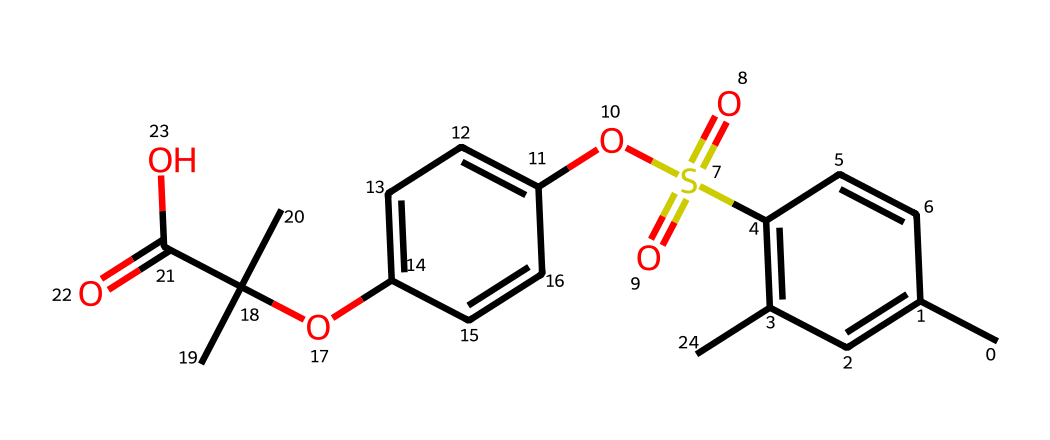What is the functional group present in this molecule? The structure contains a sulfonyl group (S(=O)(=O)), which indicates the presence of sulfonic acid derivatives often used in photoresists.
Answer: sulfonyl How many rings are in the structure? Upon examining the chemical structure, there are two aromatic rings present based on the presence of multiple carbon-carbon double bonds in a cyclic arrangement.
Answer: two What is the total number of carbon atoms in the molecule? Counting the carbon atoms in the structure, there are a total of 18 carbon atoms in the entire molecular structure.
Answer: 18 What type of compound is represented by this structure? The presence of both aromatic rings and functional groups such as esters and sulfonyl indicates that this compound is a type of photoresist, commonly used in photolithography processes.
Answer: photoresist Does this molecule contain ester functional groups? By analyzing the structure, we can see the presence of ester groups due to the –OC(=O)– linkages which connect different parts of the molecule.
Answer: yes 